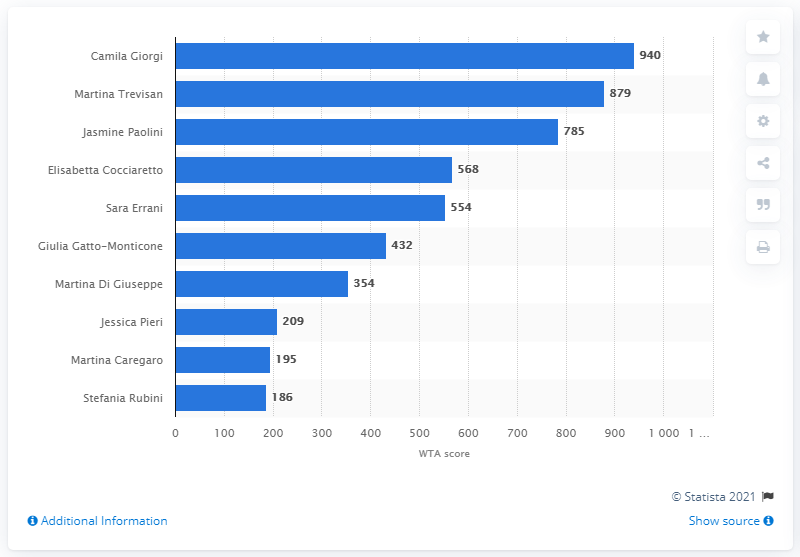Give some essential details in this illustration. As of the survey period, Martina Trevisan ranked 83rd in the WTA world ranking. Camila Giorgi scored 940 WTA points. As of October 2020, Camila Giorgi was the leading Italian female tennis player. 